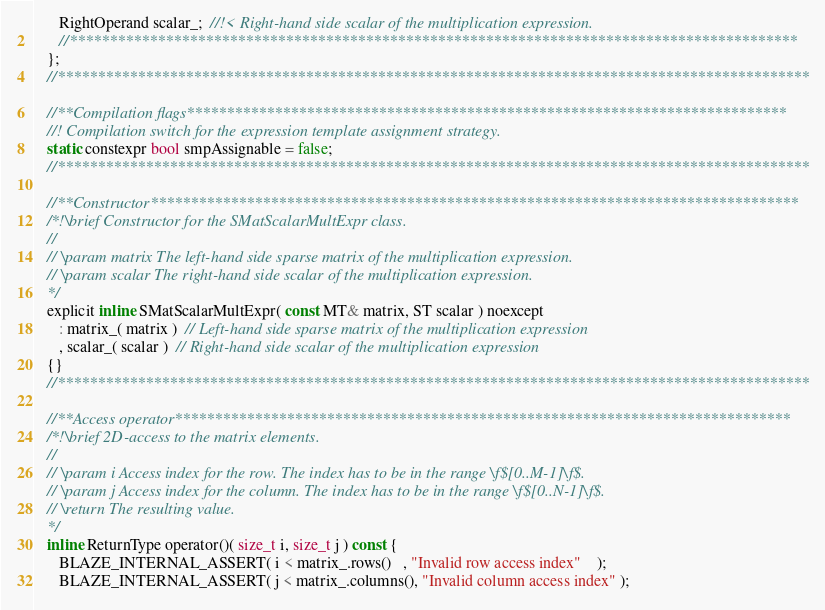<code> <loc_0><loc_0><loc_500><loc_500><_C_>      RightOperand scalar_;  //!< Right-hand side scalar of the multiplication expression.
      //*******************************************************************************************
   };
   //**********************************************************************************************

   //**Compilation flags***************************************************************************
   //! Compilation switch for the expression template assignment strategy.
   static constexpr bool smpAssignable = false;
   //**********************************************************************************************

   //**Constructor*********************************************************************************
   /*!\brief Constructor for the SMatScalarMultExpr class.
   //
   // \param matrix The left-hand side sparse matrix of the multiplication expression.
   // \param scalar The right-hand side scalar of the multiplication expression.
   */
   explicit inline SMatScalarMultExpr( const MT& matrix, ST scalar ) noexcept
      : matrix_( matrix )  // Left-hand side sparse matrix of the multiplication expression
      , scalar_( scalar )  // Right-hand side scalar of the multiplication expression
   {}
   //**********************************************************************************************

   //**Access operator*****************************************************************************
   /*!\brief 2D-access to the matrix elements.
   //
   // \param i Access index for the row. The index has to be in the range \f$[0..M-1]\f$.
   // \param j Access index for the column. The index has to be in the range \f$[0..N-1]\f$.
   // \return The resulting value.
   */
   inline ReturnType operator()( size_t i, size_t j ) const {
      BLAZE_INTERNAL_ASSERT( i < matrix_.rows()   , "Invalid row access index"    );
      BLAZE_INTERNAL_ASSERT( j < matrix_.columns(), "Invalid column access index" );</code> 